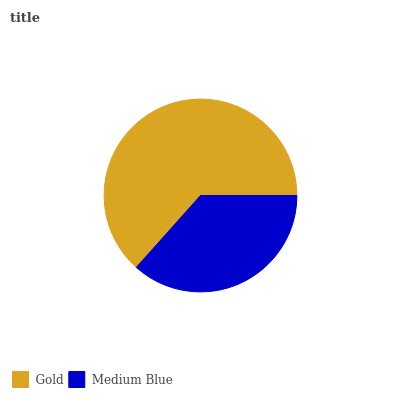Is Medium Blue the minimum?
Answer yes or no. Yes. Is Gold the maximum?
Answer yes or no. Yes. Is Medium Blue the maximum?
Answer yes or no. No. Is Gold greater than Medium Blue?
Answer yes or no. Yes. Is Medium Blue less than Gold?
Answer yes or no. Yes. Is Medium Blue greater than Gold?
Answer yes or no. No. Is Gold less than Medium Blue?
Answer yes or no. No. Is Gold the high median?
Answer yes or no. Yes. Is Medium Blue the low median?
Answer yes or no. Yes. Is Medium Blue the high median?
Answer yes or no. No. Is Gold the low median?
Answer yes or no. No. 